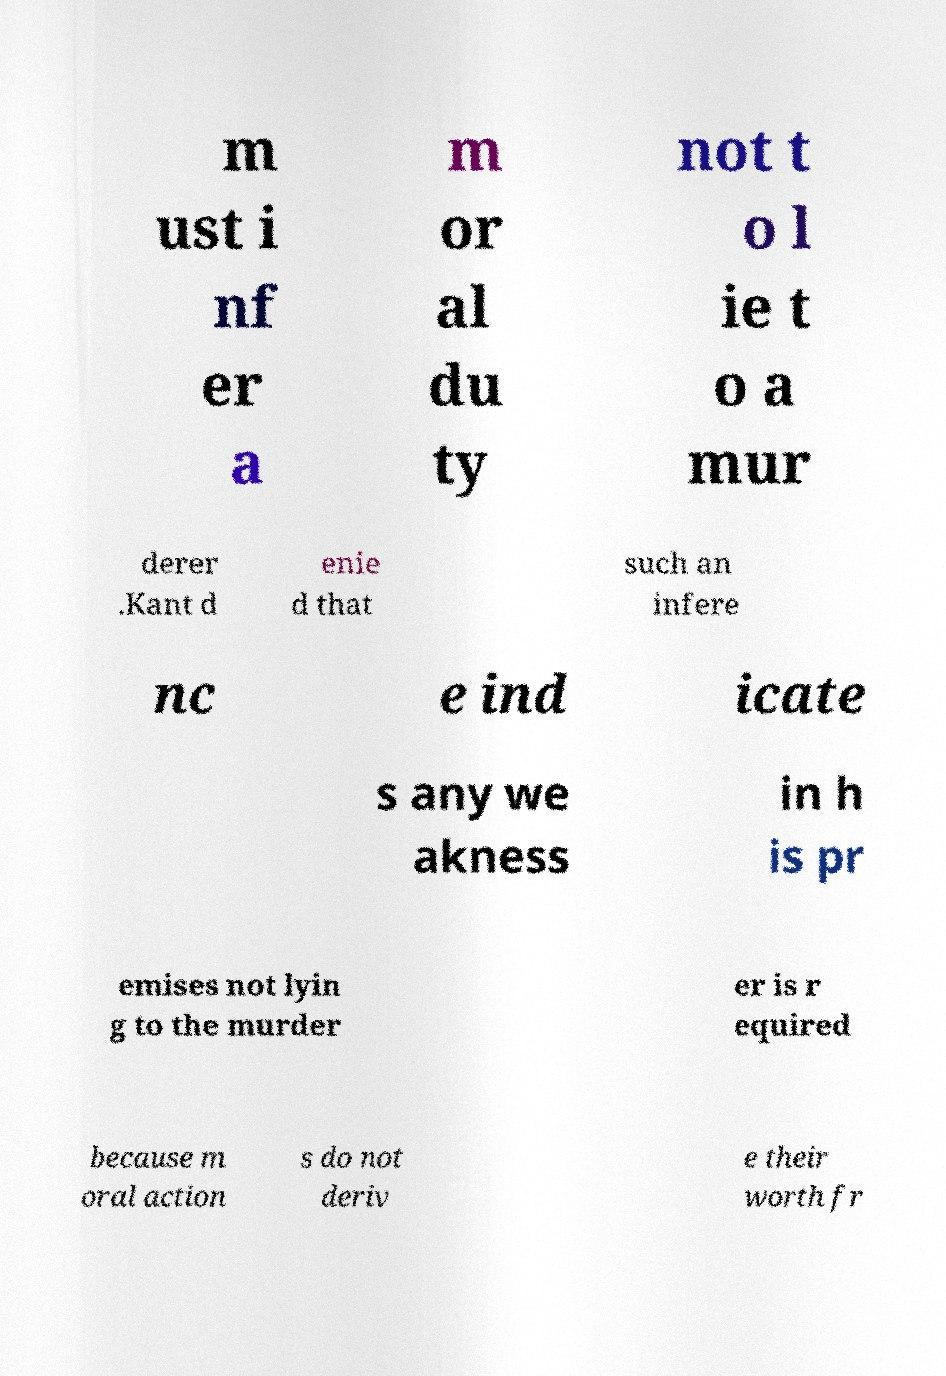Please read and relay the text visible in this image. What does it say? m ust i nf er a m or al du ty not t o l ie t o a mur derer .Kant d enie d that such an infere nc e ind icate s any we akness in h is pr emises not lyin g to the murder er is r equired because m oral action s do not deriv e their worth fr 